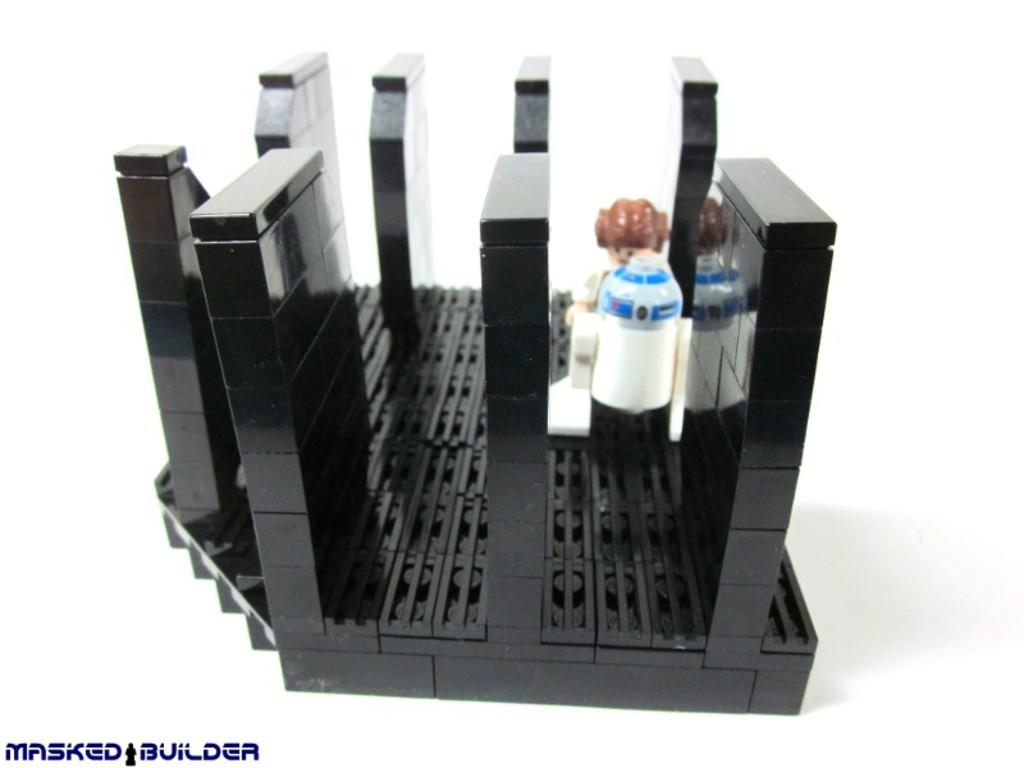<image>
Render a clear and concise summary of the photo. R2D2 lego with Masked Builder in the corner 